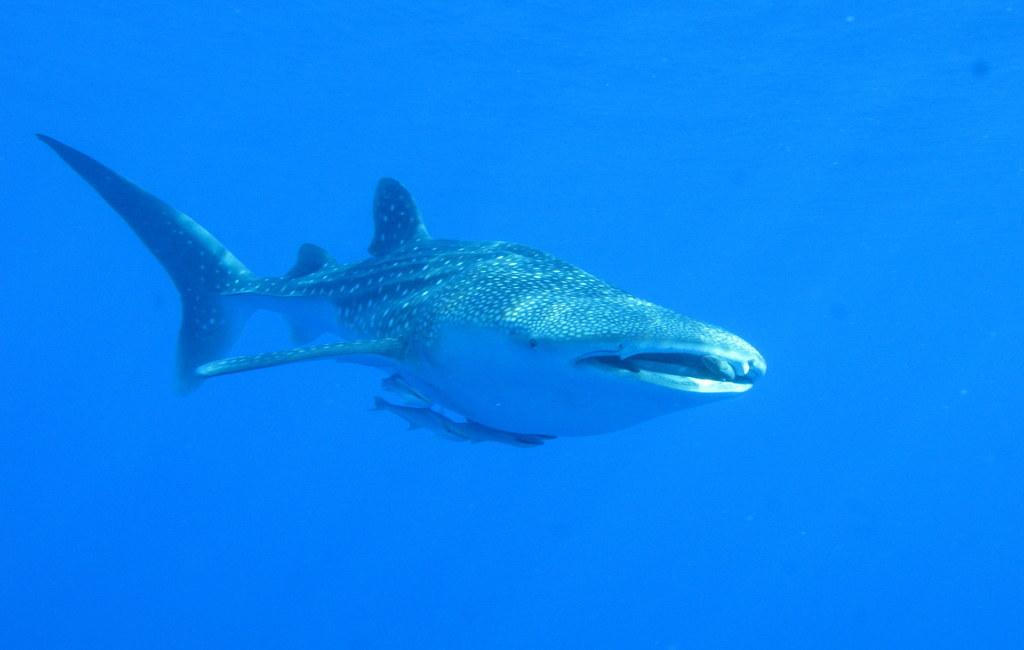What is the main subject of the image? There is a whale in the middle of the image. Where was the image taken? The image was taken underwater. How many clocks can be seen hanging in the yard in the image? There are no clocks or yards present in the image; it features a whale underwater. 